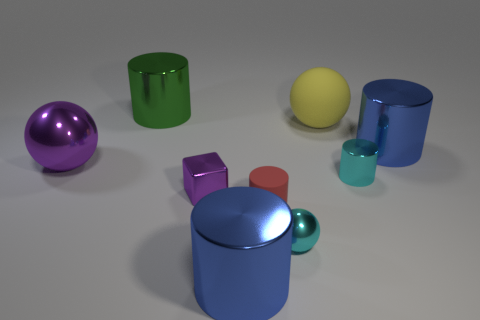Subtract all yellow cylinders. Subtract all green spheres. How many cylinders are left? 5 Add 1 cubes. How many objects exist? 10 Subtract all cylinders. How many objects are left? 4 Subtract 0 gray spheres. How many objects are left? 9 Subtract all large yellow metallic cylinders. Subtract all large shiny objects. How many objects are left? 5 Add 4 cyan objects. How many cyan objects are left? 6 Add 5 small green matte balls. How many small green matte balls exist? 5 